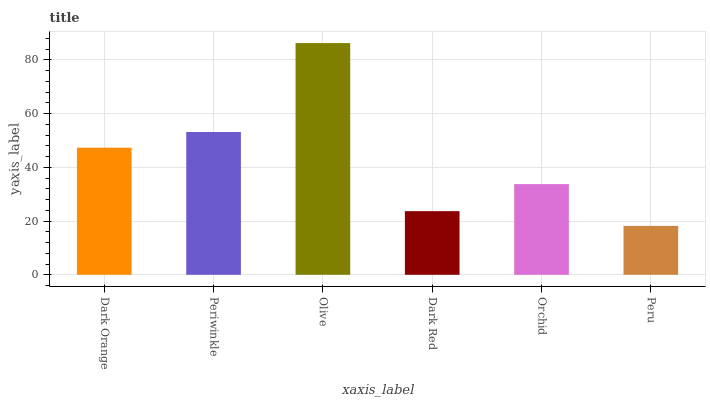Is Peru the minimum?
Answer yes or no. Yes. Is Olive the maximum?
Answer yes or no. Yes. Is Periwinkle the minimum?
Answer yes or no. No. Is Periwinkle the maximum?
Answer yes or no. No. Is Periwinkle greater than Dark Orange?
Answer yes or no. Yes. Is Dark Orange less than Periwinkle?
Answer yes or no. Yes. Is Dark Orange greater than Periwinkle?
Answer yes or no. No. Is Periwinkle less than Dark Orange?
Answer yes or no. No. Is Dark Orange the high median?
Answer yes or no. Yes. Is Orchid the low median?
Answer yes or no. Yes. Is Olive the high median?
Answer yes or no. No. Is Dark Orange the low median?
Answer yes or no. No. 